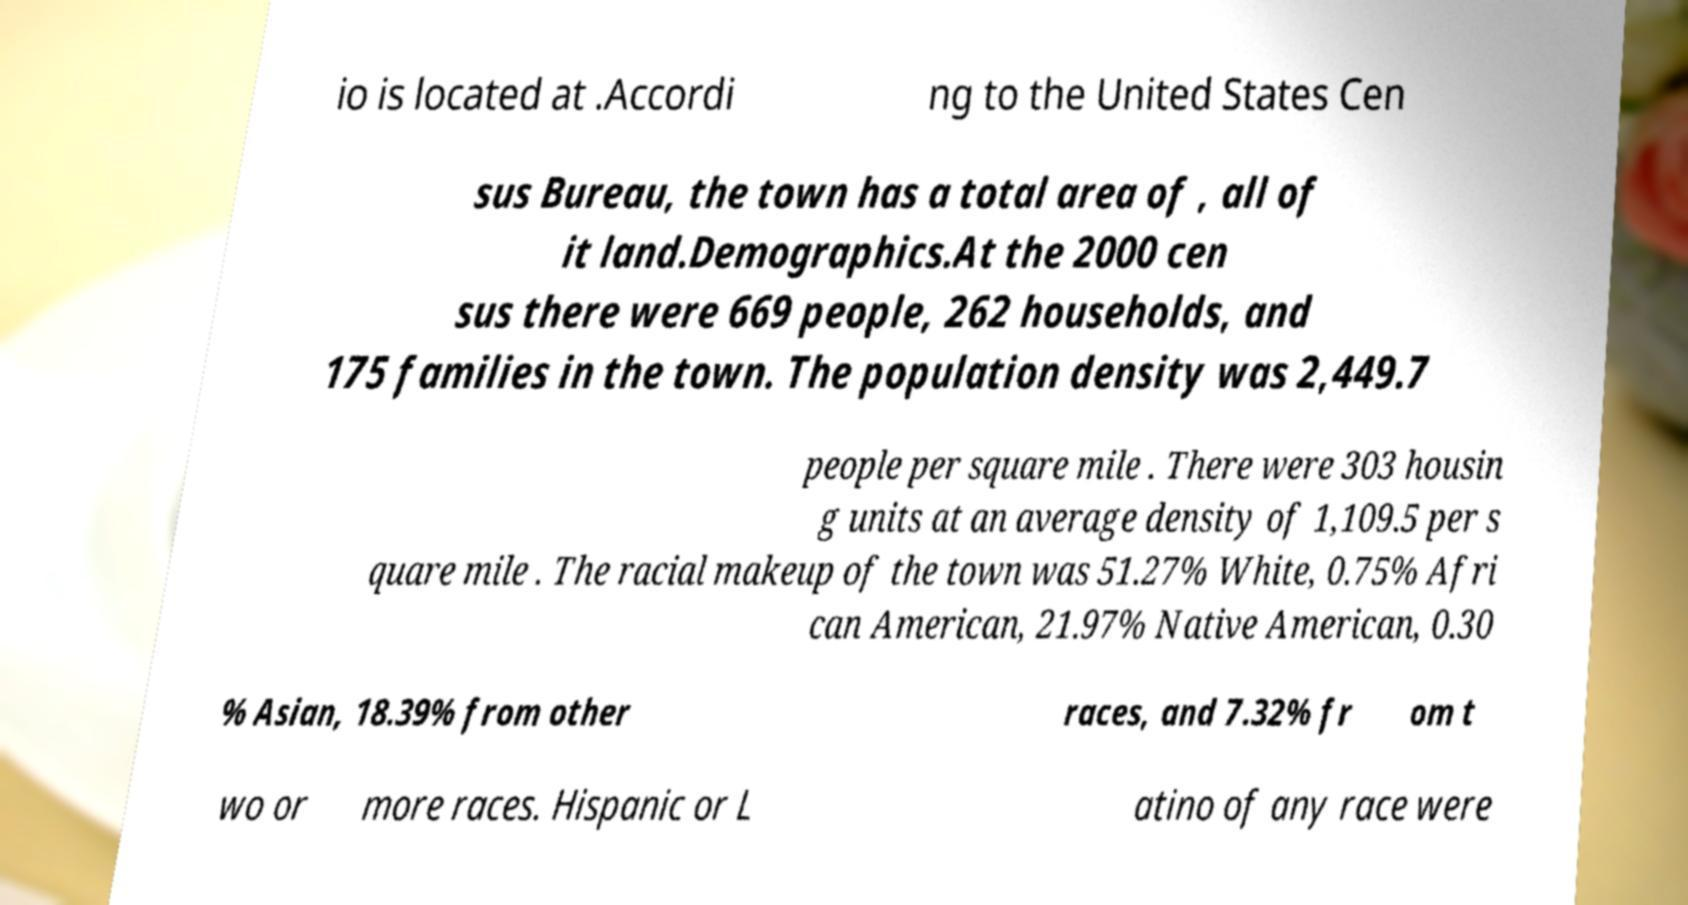Please read and relay the text visible in this image. What does it say? io is located at .Accordi ng to the United States Cen sus Bureau, the town has a total area of , all of it land.Demographics.At the 2000 cen sus there were 669 people, 262 households, and 175 families in the town. The population density was 2,449.7 people per square mile . There were 303 housin g units at an average density of 1,109.5 per s quare mile . The racial makeup of the town was 51.27% White, 0.75% Afri can American, 21.97% Native American, 0.30 % Asian, 18.39% from other races, and 7.32% fr om t wo or more races. Hispanic or L atino of any race were 